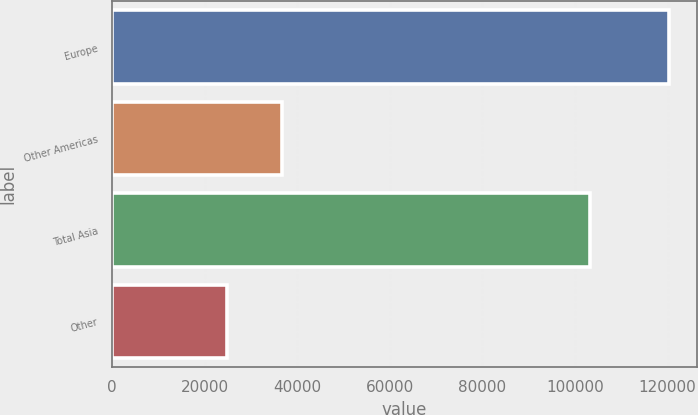Convert chart to OTSL. <chart><loc_0><loc_0><loc_500><loc_500><bar_chart><fcel>Europe<fcel>Other Americas<fcel>Total Asia<fcel>Other<nl><fcel>120362<fcel>36666<fcel>103192<fcel>24816<nl></chart> 